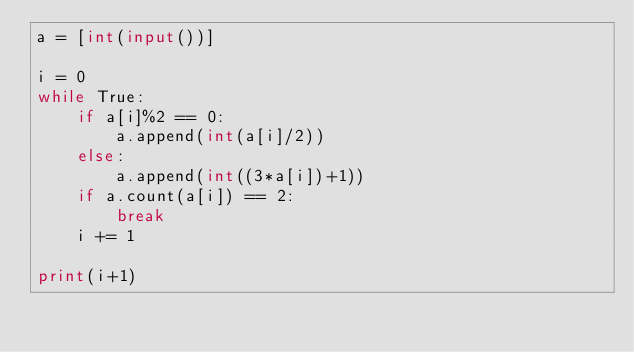Convert code to text. <code><loc_0><loc_0><loc_500><loc_500><_Python_>a = [int(input())]

i = 0
while True:
    if a[i]%2 == 0:
        a.append(int(a[i]/2))
    else:
        a.append(int((3*a[i])+1))
    if a.count(a[i]) == 2:
        break
    i += 1

print(i+1)</code> 